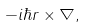Convert formula to latex. <formula><loc_0><loc_0><loc_500><loc_500>- i \hbar { r } \times \nabla ,</formula> 